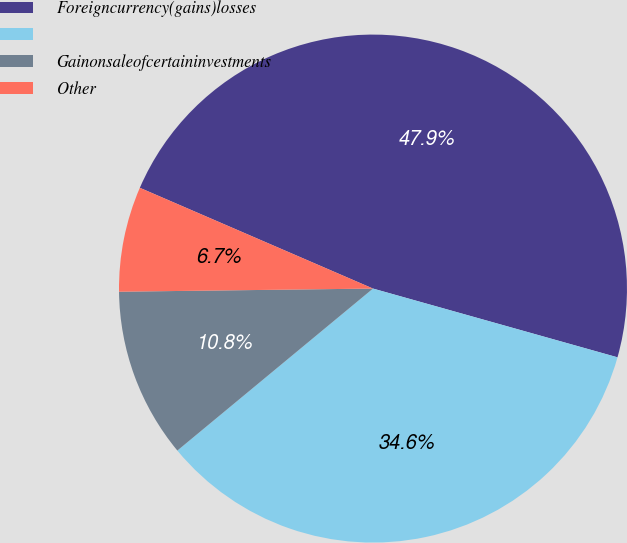Convert chart. <chart><loc_0><loc_0><loc_500><loc_500><pie_chart><fcel>Foreigncurrency(gains)losses<fcel>Unnamed: 1<fcel>Gainonsaleofcertaininvestments<fcel>Other<nl><fcel>47.87%<fcel>34.63%<fcel>10.81%<fcel>6.69%<nl></chart> 